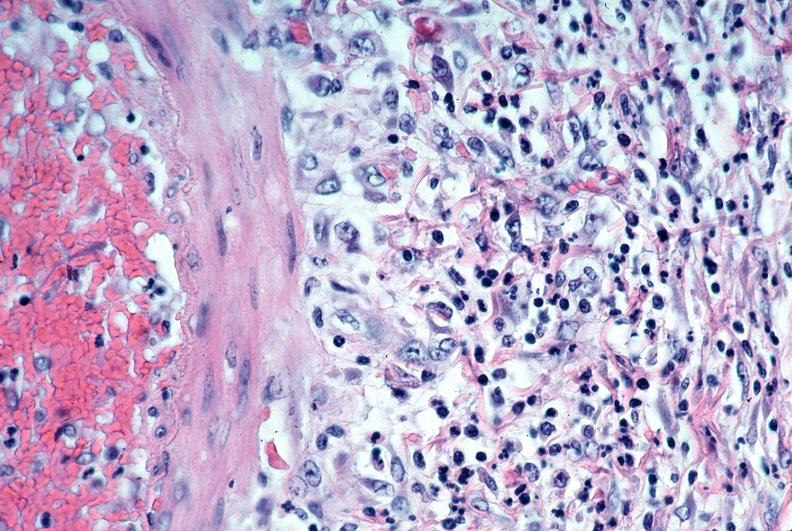what is present?
Answer the question using a single word or phrase. Cardiovascular 